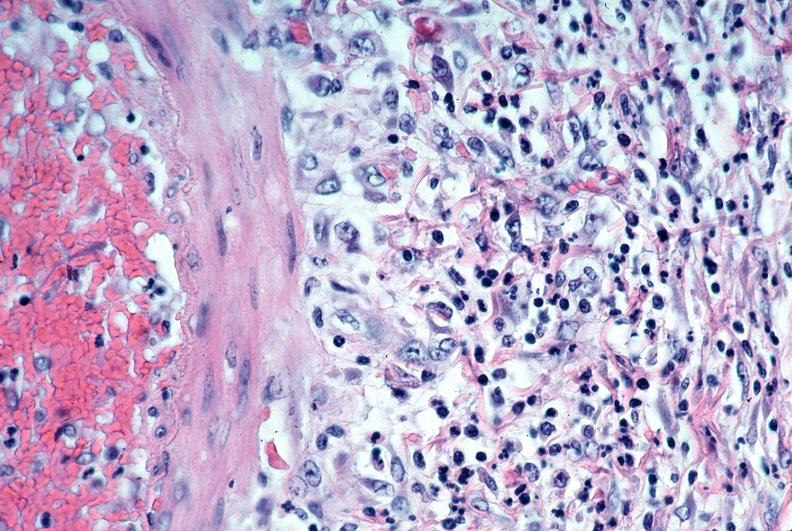what is present?
Answer the question using a single word or phrase. Cardiovascular 